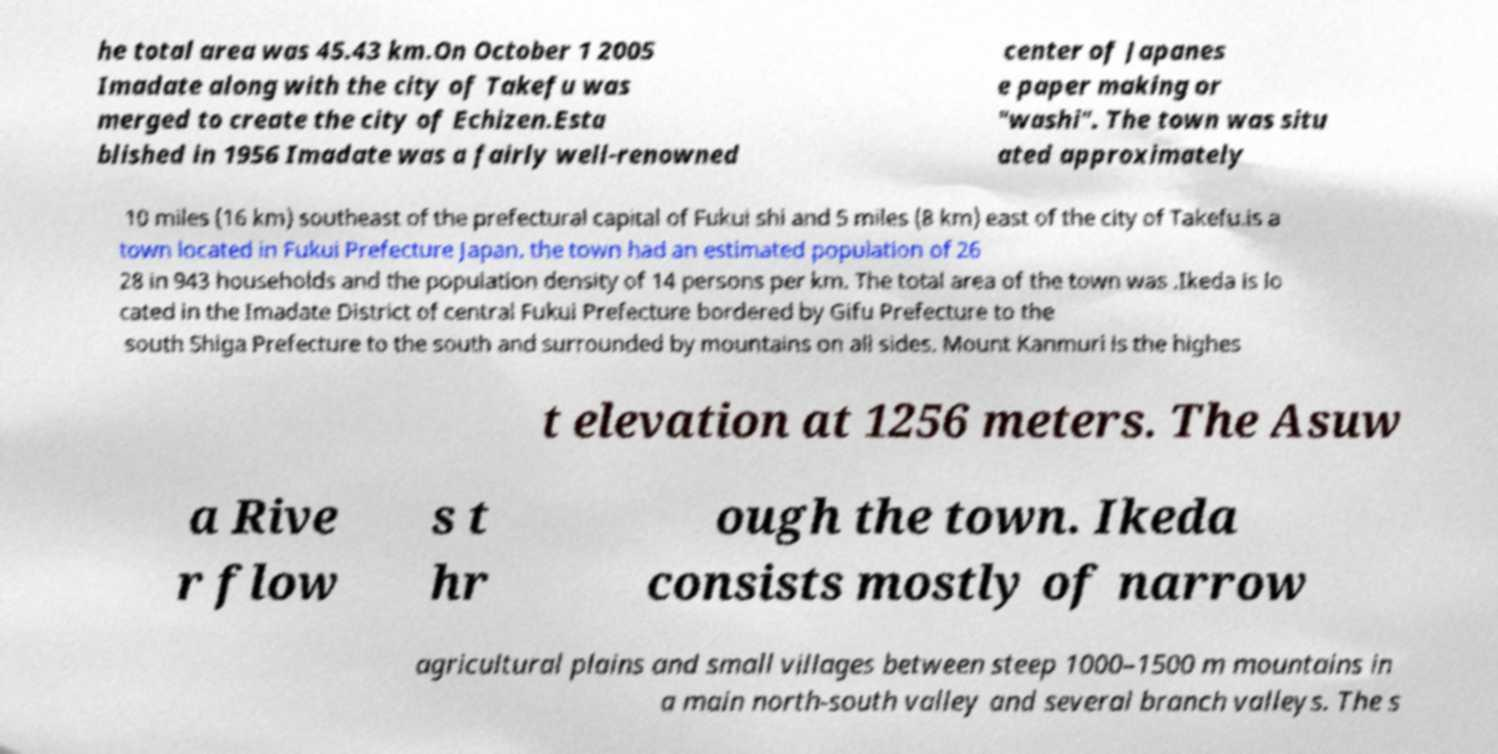Please read and relay the text visible in this image. What does it say? he total area was 45.43 km.On October 1 2005 Imadate along with the city of Takefu was merged to create the city of Echizen.Esta blished in 1956 Imadate was a fairly well-renowned center of Japanes e paper making or "washi". The town was situ ated approximately 10 miles (16 km) southeast of the prefectural capital of Fukui shi and 5 miles (8 km) east of the city of Takefu.is a town located in Fukui Prefecture Japan. the town had an estimated population of 26 28 in 943 households and the population density of 14 persons per km. The total area of the town was .Ikeda is lo cated in the Imadate District of central Fukui Prefecture bordered by Gifu Prefecture to the south Shiga Prefecture to the south and surrounded by mountains on all sides. Mount Kanmuri is the highes t elevation at 1256 meters. The Asuw a Rive r flow s t hr ough the town. Ikeda consists mostly of narrow agricultural plains and small villages between steep 1000–1500 m mountains in a main north-south valley and several branch valleys. The s 